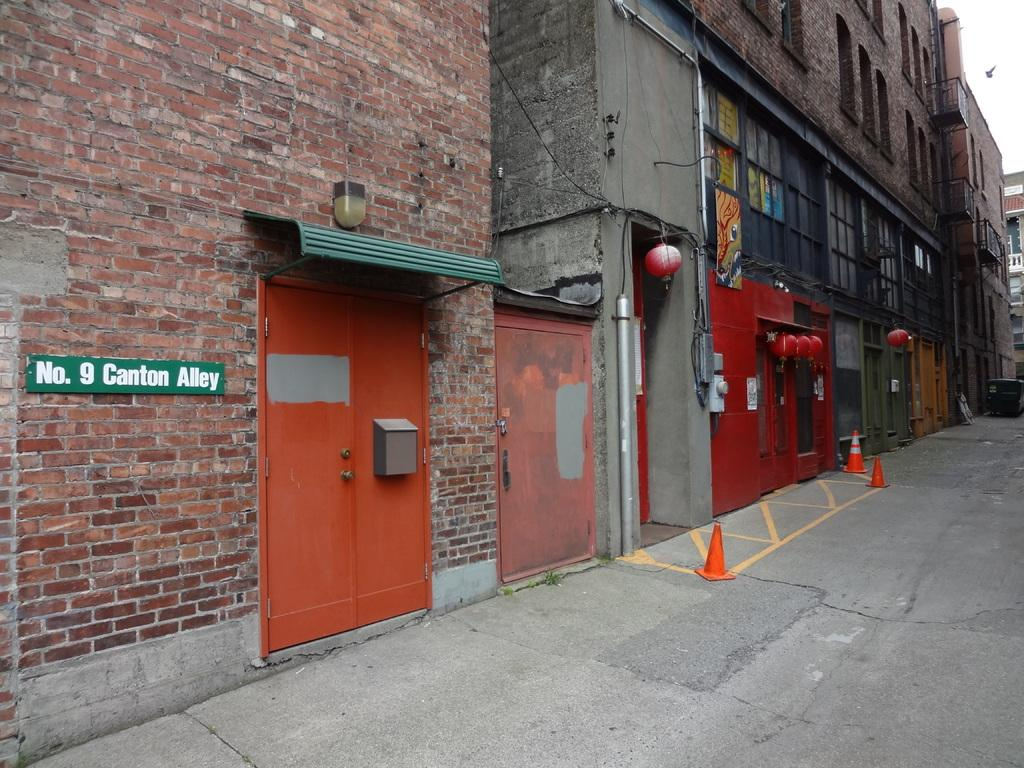What type of structures can be seen in the image? There are buildings in the image. What safety equipment is present in the image? There are safety cones in the image. What type of pathway is visible in the image? There is a road in the image. What type of lighting is present in the image? There is a light in the image. What type of signage is present in the image? There is a board in the image. What is visible in the background of the image? The sky is visible in the image. What type of edge can be seen on the buildings in the image? There is no specific edge mentioned or visible on the buildings in the image. What is the cause of the light being present in the image? The cause of the light being present in the image is not mentioned or visible in the image. 